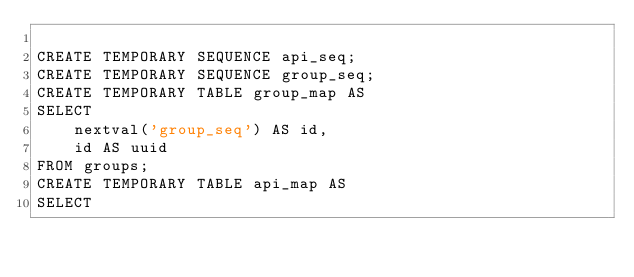Convert code to text. <code><loc_0><loc_0><loc_500><loc_500><_SQL_>
CREATE TEMPORARY SEQUENCE api_seq;
CREATE TEMPORARY SEQUENCE group_seq;
CREATE TEMPORARY TABLE group_map AS
SELECT
    nextval('group_seq') AS id,
    id AS uuid
FROM groups;
CREATE TEMPORARY TABLE api_map AS
SELECT</code> 